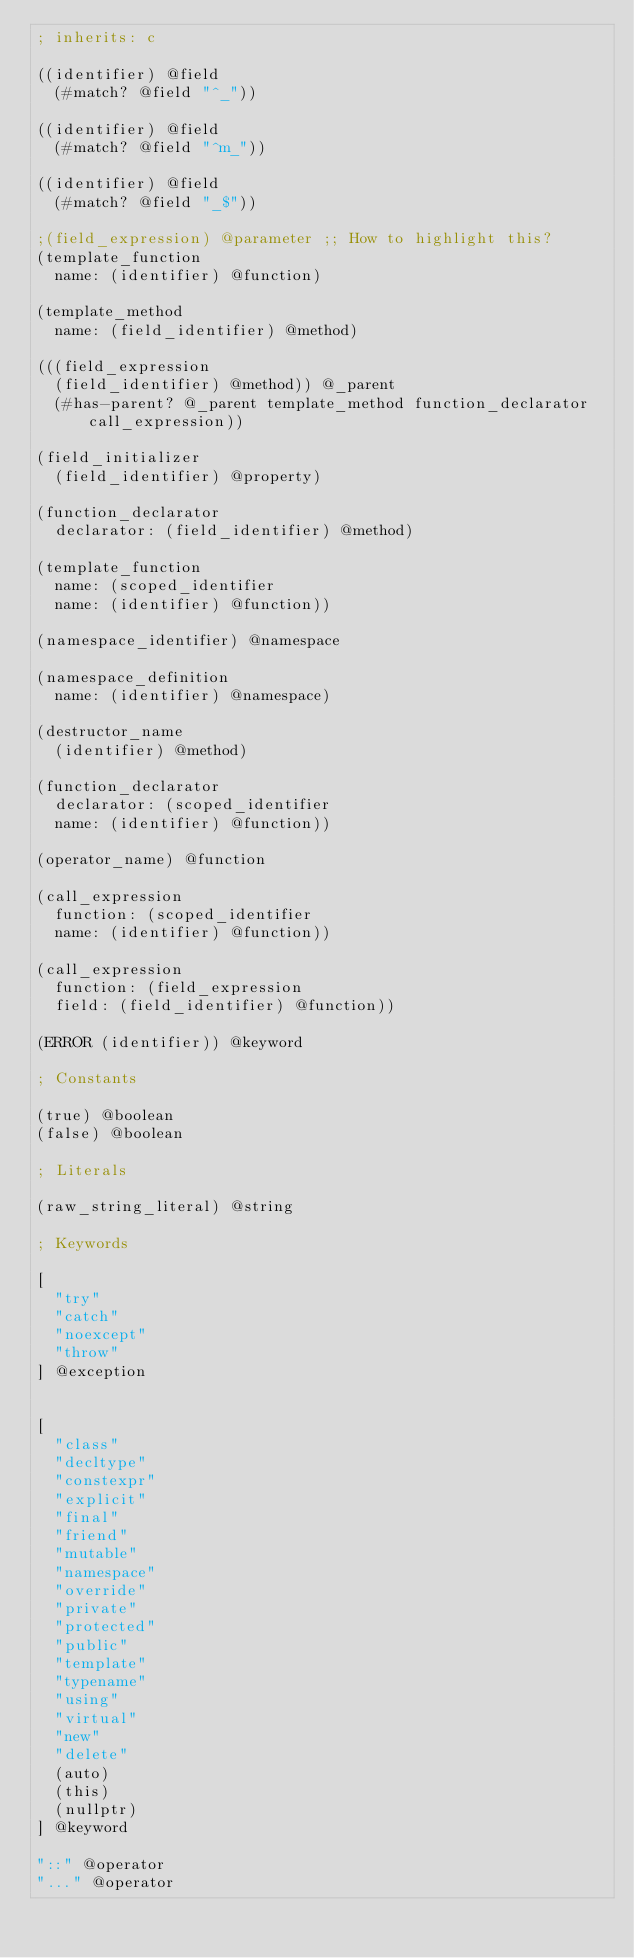Convert code to text. <code><loc_0><loc_0><loc_500><loc_500><_Scheme_>; inherits: c

((identifier) @field
	(#match? @field "^_"))

((identifier) @field
	(#match? @field "^m_"))

((identifier) @field
	(#match? @field "_$"))

;(field_expression) @parameter ;; How to highlight this?
(template_function
	name: (identifier) @function)

(template_method
	name: (field_identifier) @method)

(((field_expression
	(field_identifier) @method)) @_parent
	(#has-parent? @_parent template_method function_declarator call_expression))

(field_initializer
	(field_identifier) @property)

(function_declarator
	declarator: (field_identifier) @method)

(template_function
	name: (scoped_identifier
	name: (identifier) @function))

(namespace_identifier) @namespace

(namespace_definition
	name: (identifier) @namespace)

(destructor_name
	(identifier) @method)

(function_declarator
	declarator: (scoped_identifier
	name: (identifier) @function))

(operator_name) @function

(call_expression
	function: (scoped_identifier
	name: (identifier) @function))

(call_expression
	function: (field_expression
	field: (field_identifier) @function))

(ERROR (identifier)) @keyword

; Constants

(true) @boolean
(false) @boolean

; Literals

(raw_string_literal) @string

; Keywords

[
	"try"
	"catch"
	"noexcept"
	"throw"
] @exception


[
	"class"
	"decltype"
	"constexpr"
	"explicit"
	"final"
	"friend"
	"mutable"
	"namespace"
	"override"
	"private"
	"protected"
	"public"
	"template"
	"typename"
	"using"
	"virtual"
	"new"
	"delete"
	(auto)
	(this)
	(nullptr)
] @keyword

"::" @operator
"..." @operator
</code> 